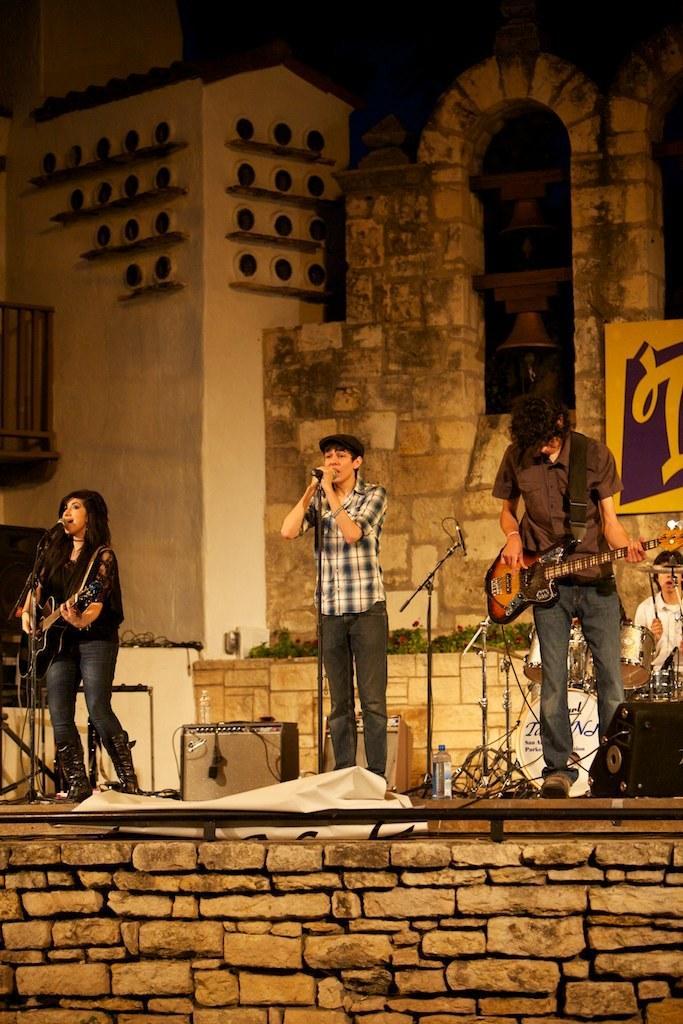How would you summarize this image in a sentence or two? In this image we can see this two persons are holding a guitar in their hands and playing it. This man is singing through the mic. In the background we can see this man is playing electronic drums. 